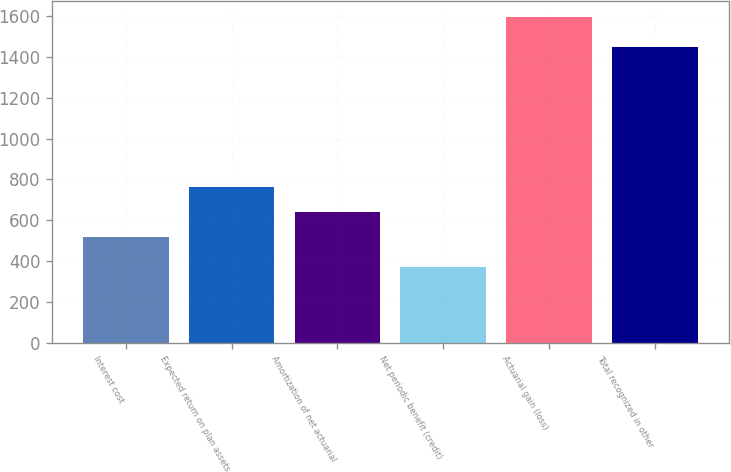<chart> <loc_0><loc_0><loc_500><loc_500><bar_chart><fcel>Interest cost<fcel>Expected return on plan assets<fcel>Amortization of net actuarial<fcel>Net periodic benefit (credit)<fcel>Actuarial gain (loss)<fcel>Total recognized in other<nl><fcel>520<fcel>765<fcel>642.5<fcel>371<fcel>1596<fcel>1450<nl></chart> 